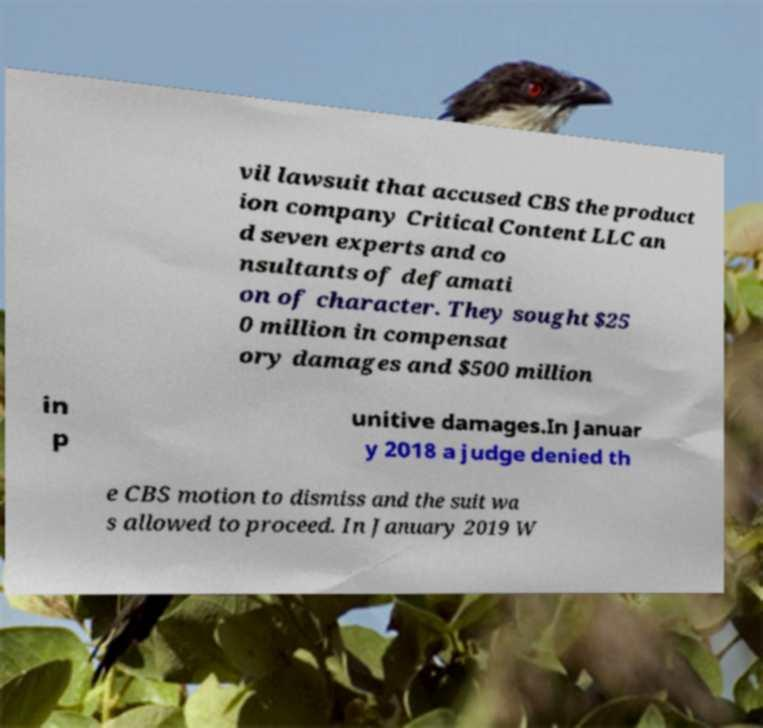Could you extract and type out the text from this image? vil lawsuit that accused CBS the product ion company Critical Content LLC an d seven experts and co nsultants of defamati on of character. They sought $25 0 million in compensat ory damages and $500 million in p unitive damages.In Januar y 2018 a judge denied th e CBS motion to dismiss and the suit wa s allowed to proceed. In January 2019 W 